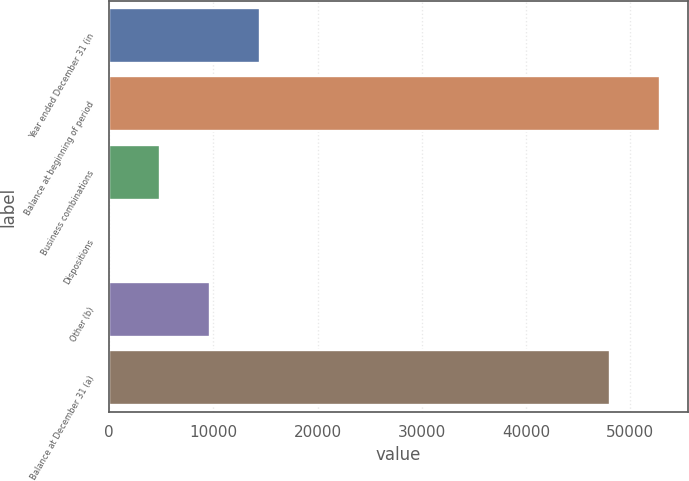<chart> <loc_0><loc_0><loc_500><loc_500><bar_chart><fcel>Year ended December 31 (in<fcel>Balance at beginning of period<fcel>Business combinations<fcel>Dispositions<fcel>Other (b)<fcel>Balance at December 31 (a)<nl><fcel>14456<fcel>52898<fcel>4822<fcel>5<fcel>9639<fcel>48081<nl></chart> 